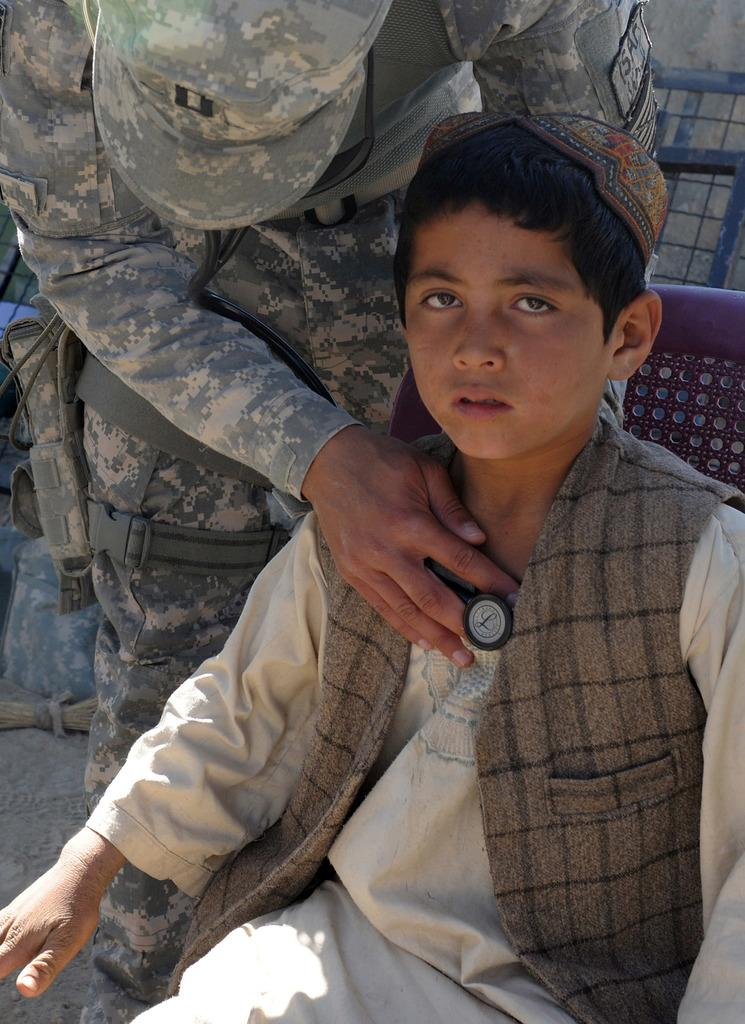What is the boy in the image doing? The boy is sitting on a chair in the image. What is the standing person holding in the image? The standing person is holding a stethoscope in the image. What can be seen in the background of the image? There is a gate visible in the background of the image. What object is located at the bottom of the image? There is a broom at the bottom of the image. What type of low activity is the boy participating in with the standing person in the image? There is no indication of a low activity or event involving the boy and the standing person in the image. 